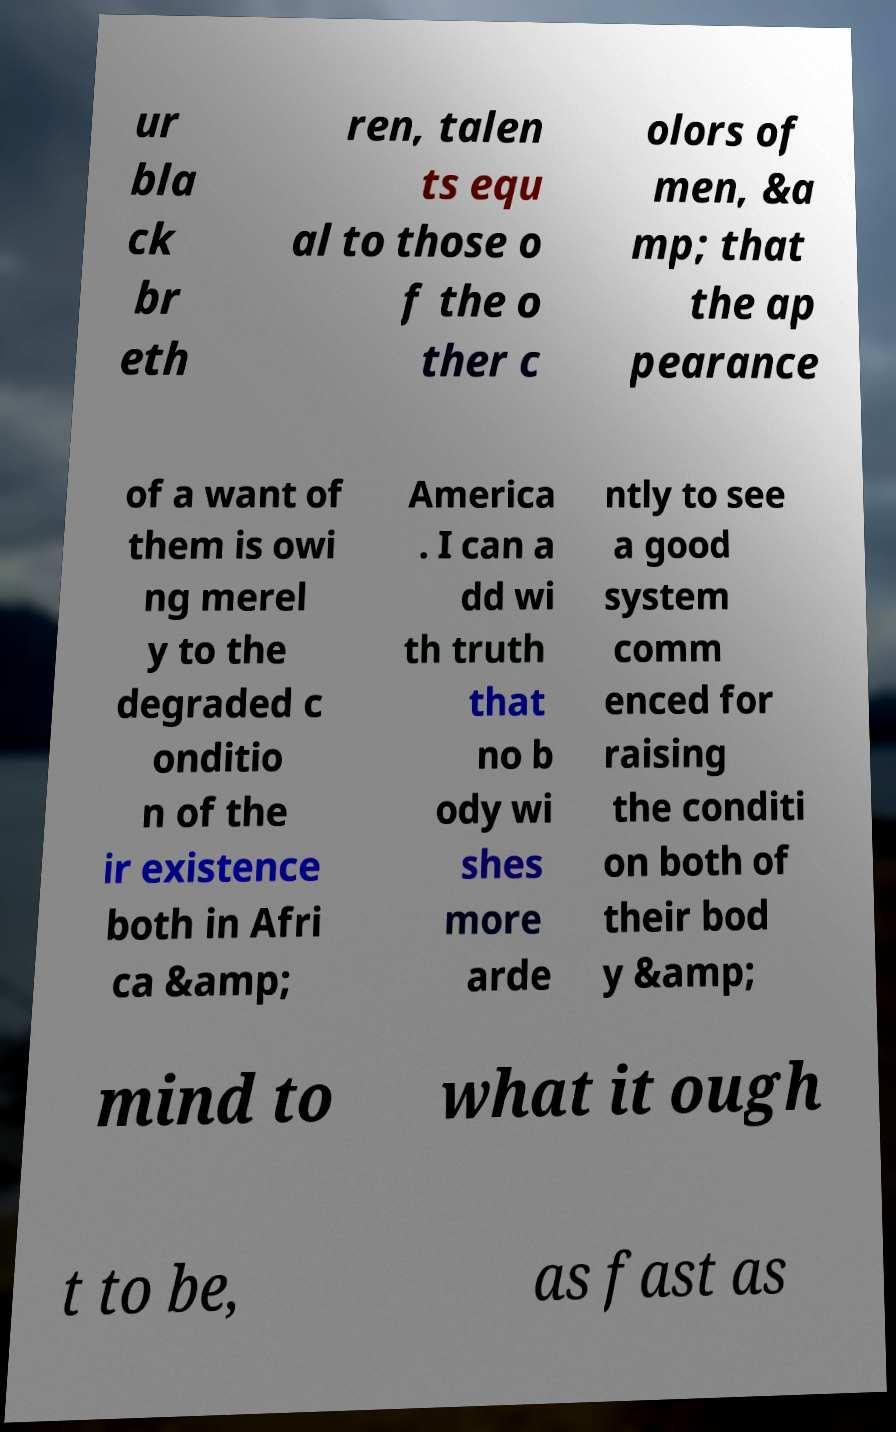Please identify and transcribe the text found in this image. ur bla ck br eth ren, talen ts equ al to those o f the o ther c olors of men, &a mp; that the ap pearance of a want of them is owi ng merel y to the degraded c onditio n of the ir existence both in Afri ca &amp; America . I can a dd wi th truth that no b ody wi shes more arde ntly to see a good system comm enced for raising the conditi on both of their bod y &amp; mind to what it ough t to be, as fast as 